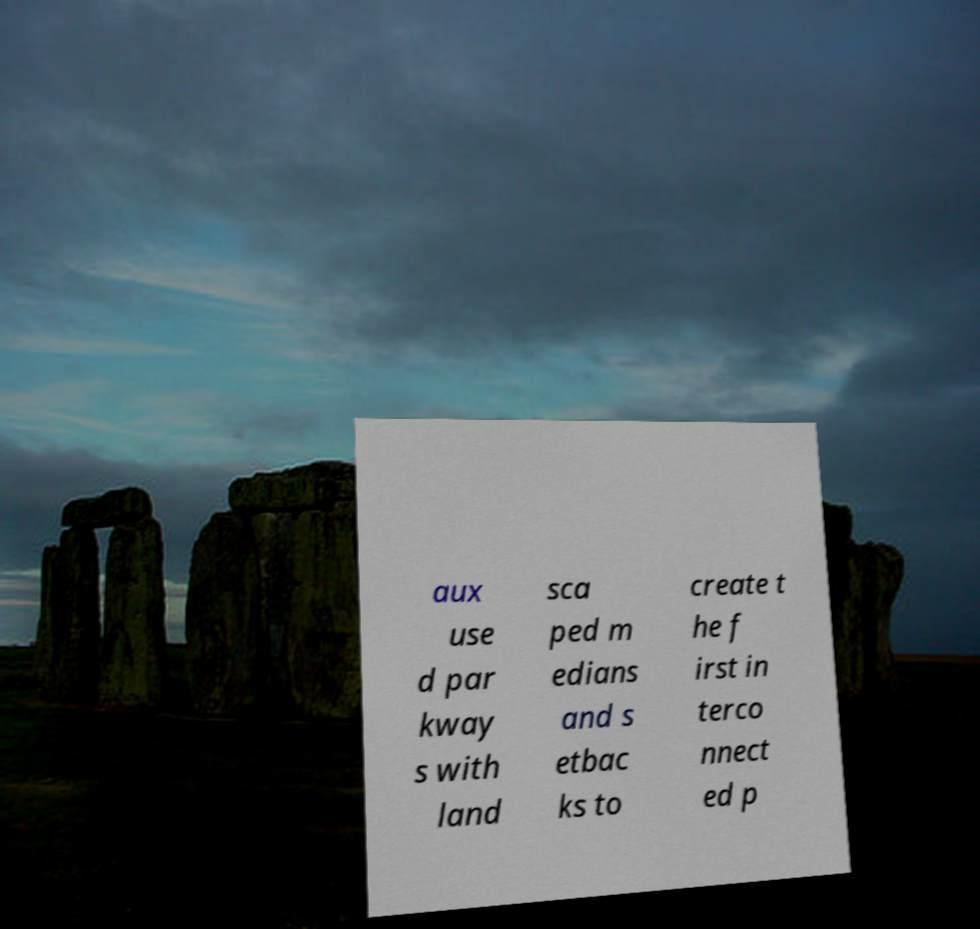Please read and relay the text visible in this image. What does it say? aux use d par kway s with land sca ped m edians and s etbac ks to create t he f irst in terco nnect ed p 